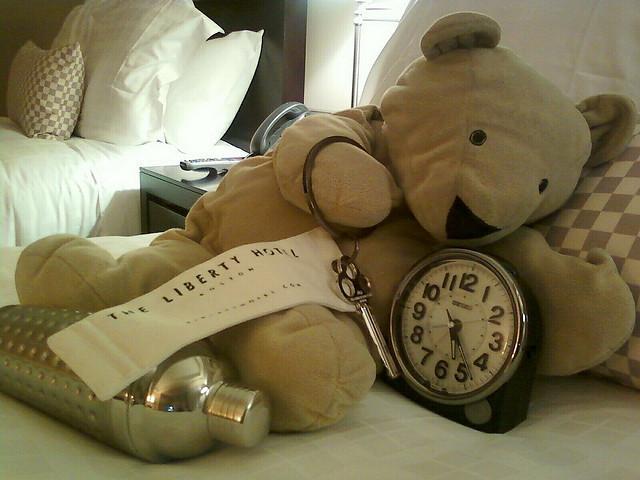Verify the accuracy of this image caption: "The teddy bear is touching the bottle.".
Answer yes or no. Yes. 